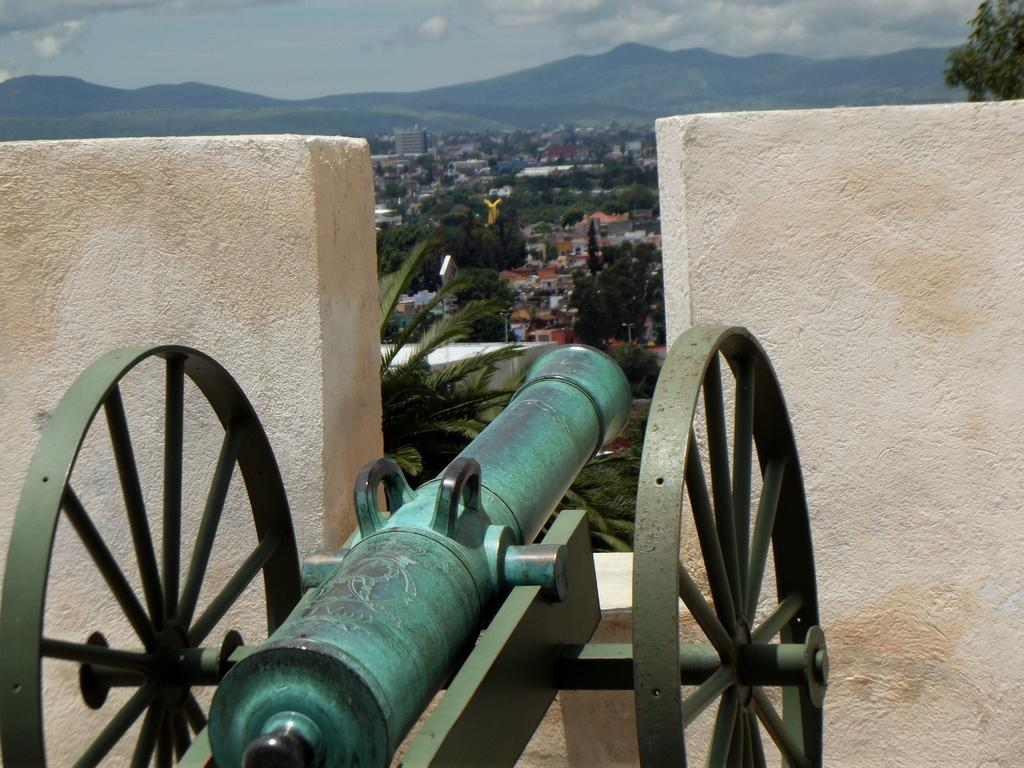What is the main object in the image? There is a canon in the image. What can be seen from left to right in the image? A wall is visible from left to right in the image. What is visible in the background of the image? There are trees, buildings, and mountains in the background of the image. What is the condition of the sky in the image? The sky is cloudy in the image. What type of calculator can be seen on the canon in the image? There is no calculator present on the canon in the image. What form does the canon take in the image? The canon is a physical object, not a form or shape. 